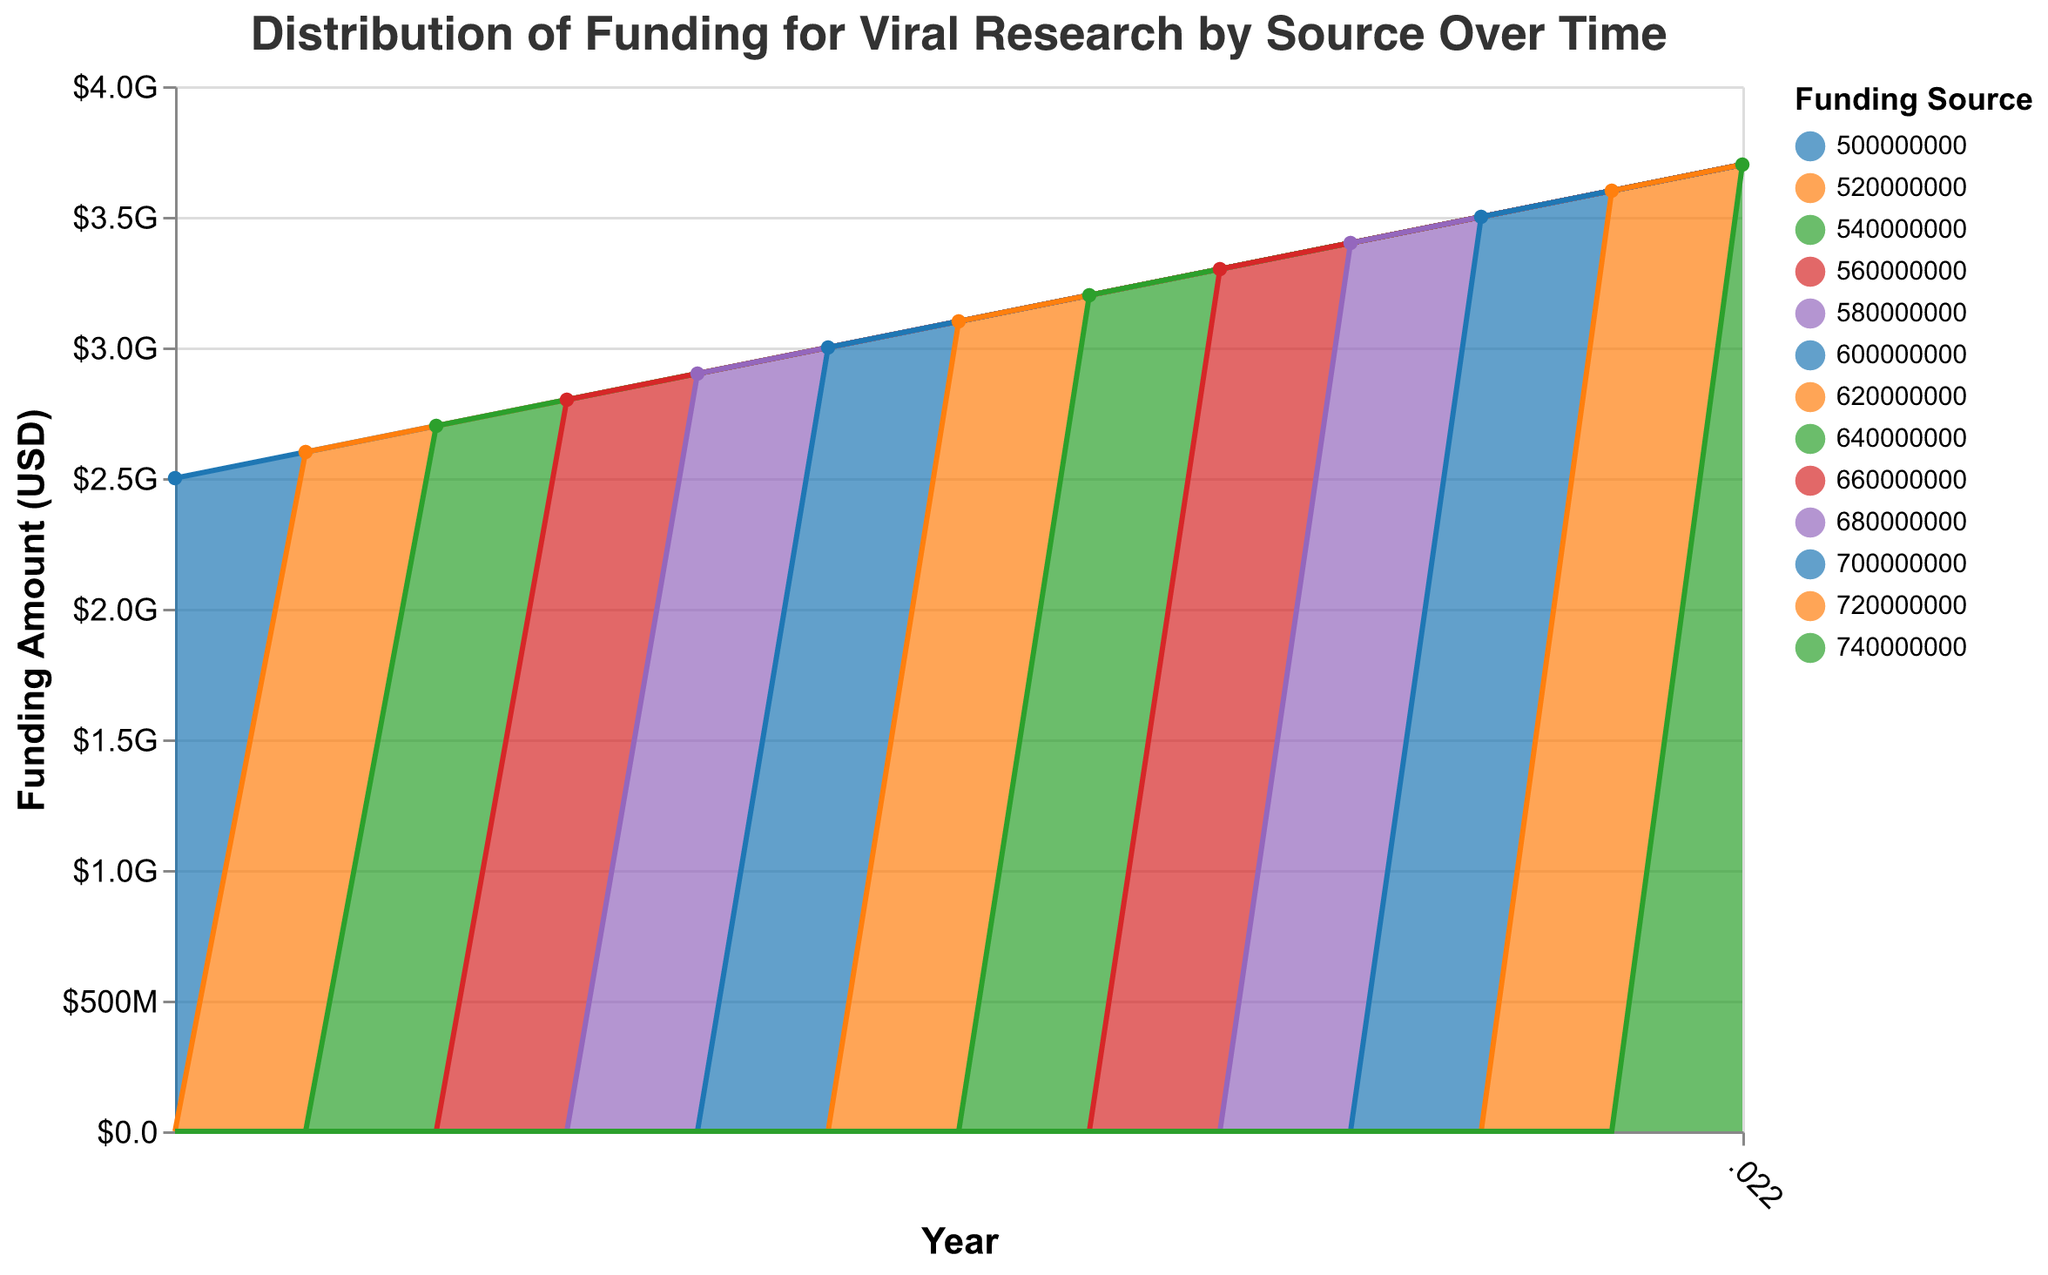what is the title of the figure? The title of the figure is usually displayed at the top of the chart. In this case, it is clearly stated in the dataset and the code.
Answer: Distribution of Funding for Viral Research by Source Over Time Which funding source received the highest amount of funding in 2010? To identify the funding source with the highest amount in 2010, look at the data points for each source. NIH received $500,000,000, which is the highest compared to others.
Answer: NIH How did the total viral research funding change from 2010 to 2022? Total funding can be found by summing all the funding sources for each year and comparing the totals for 2010 and 2022. In 2010: $500M + $200M + $150M + $100M + $250M = $1.2 billion. In 2022: $740M + $270M + $220M + $165M + $370M = $1.765 billion.
Answer: Increased What was the funding amount for the CDC in 2015? By referring to the data, the funding amount for CDC in 2015 is listed as $235,000,000.
Answer: $235,000,000 Which year saw the largest increase in NIH funding compared to the previous year? To find the largest annual increase in NIH funding, compute the yearly differences and identify the maximum. From 2019 to 2020, the increase was $20M, which is the highest single-year jump.
Answer: 2020 What's the total funding amount received by the Gates Foundation across all years? Sum the Gates Foundation funding from each year: $150M + $160M + $170M + $175M + $180M + $185M + $190M + $195M + $200M + $205M + $210M + $215M + $220M = $2.355 billion.
Answer: $2.355 billion How much more funding did the NIH receive compared to the EU in 2022? Look at the NIH and EU funding amounts in 2022, which are $740M and $370M respectively. Subtract the EU amount from the NIH amount: $740M - $370M = $370M.
Answer: $370,000,000 Which two funding sources increased exactly $10,000,000 from 2019 to 2020? Comparing the funding amounts from 2019 to 2020, both the Wellcome Trust ($150M to $155M) and the EU ($340M to $350M) increased by exactly $10M.
Answer: Wellcome Trust and EU How did the sum of all funding sources in 2015 compare to 2010? Sum the funding values for 2010: $1.2 billion and for 2015: $1.45 billion. Compare the sums: $1.45 billion - $1.2 billion = $0.25 billion more in 2015.
Answer: Increased by $0.25 billion When did Gates Foundation funding first surpass $200,000,000? The Gates Foundation funding surpassed $200M in 2018 when it reached $200M.
Answer: 2018 